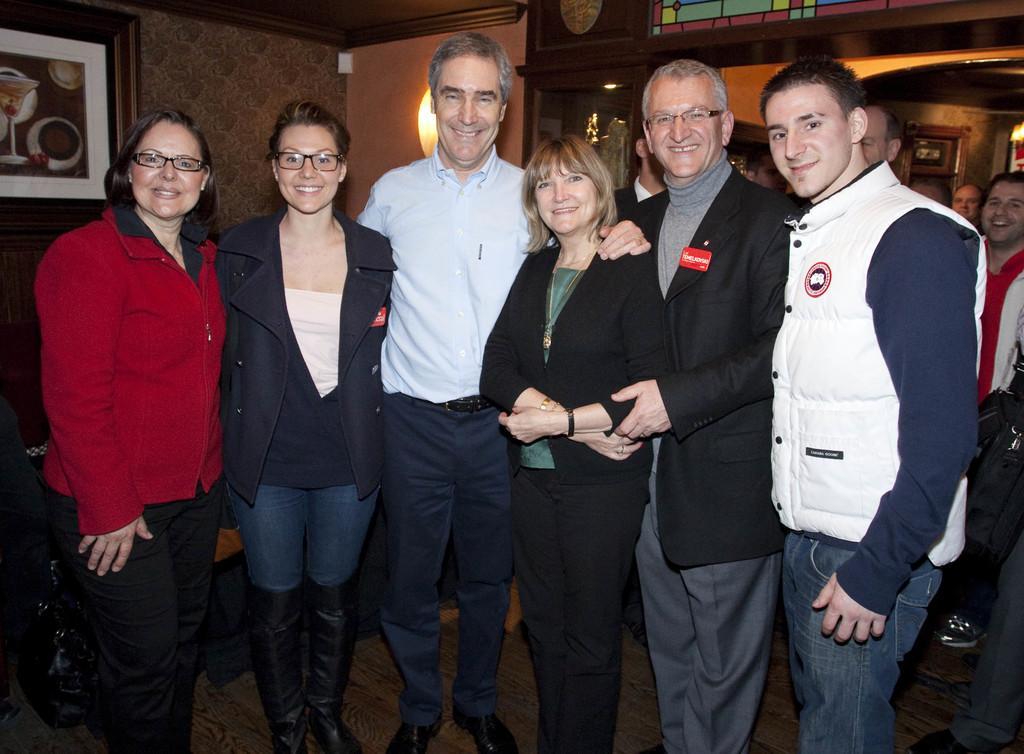In one or two sentences, can you explain what this image depicts? The Picture shows few people standing and few of them wore spectacles and we see smile on their faces and we see a photo frame on the wall and we see lighting. 